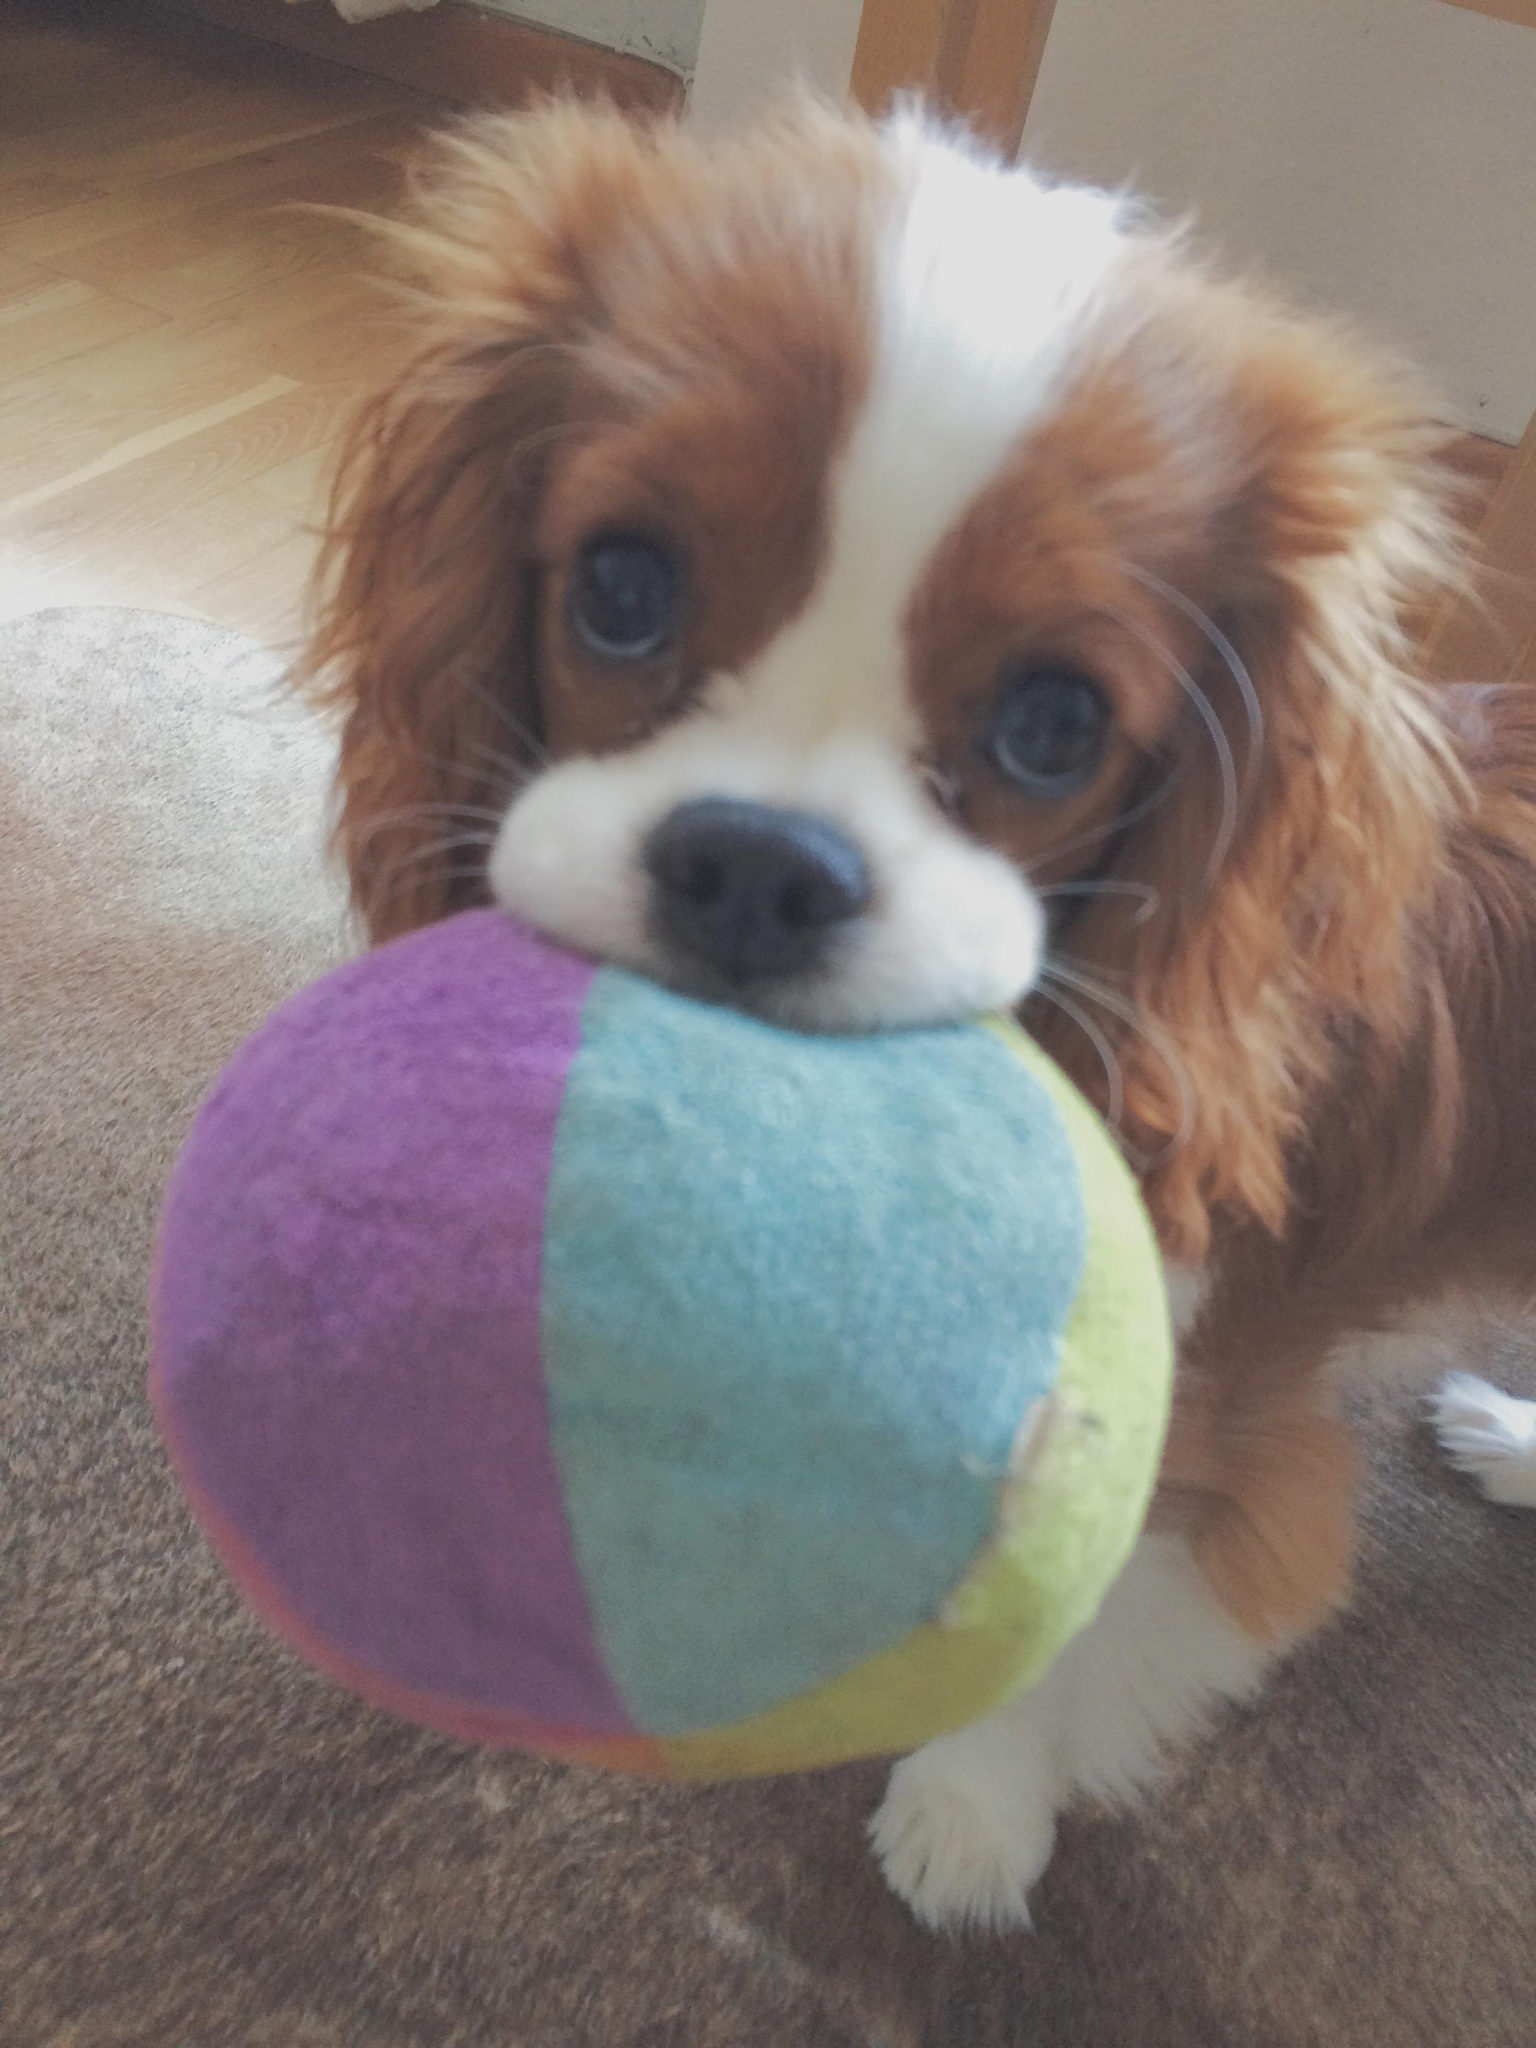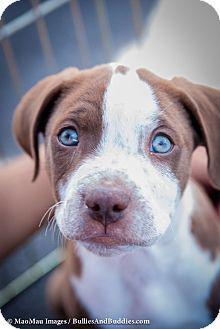The first image is the image on the left, the second image is the image on the right. For the images displayed, is the sentence "All the dogs are looking straight ahead." factually correct? Answer yes or no. Yes. The first image is the image on the left, the second image is the image on the right. For the images displayed, is the sentence "One of the brown and white dogs has a toy." factually correct? Answer yes or no. Yes. 